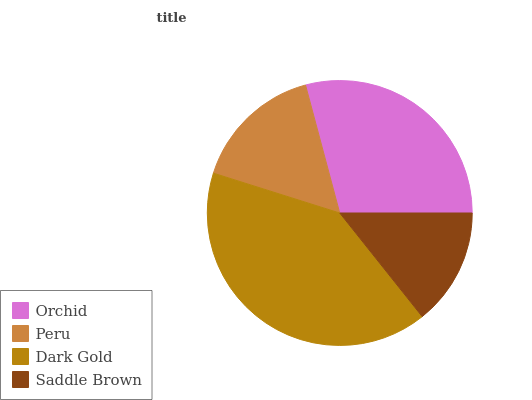Is Saddle Brown the minimum?
Answer yes or no. Yes. Is Dark Gold the maximum?
Answer yes or no. Yes. Is Peru the minimum?
Answer yes or no. No. Is Peru the maximum?
Answer yes or no. No. Is Orchid greater than Peru?
Answer yes or no. Yes. Is Peru less than Orchid?
Answer yes or no. Yes. Is Peru greater than Orchid?
Answer yes or no. No. Is Orchid less than Peru?
Answer yes or no. No. Is Orchid the high median?
Answer yes or no. Yes. Is Peru the low median?
Answer yes or no. Yes. Is Peru the high median?
Answer yes or no. No. Is Orchid the low median?
Answer yes or no. No. 